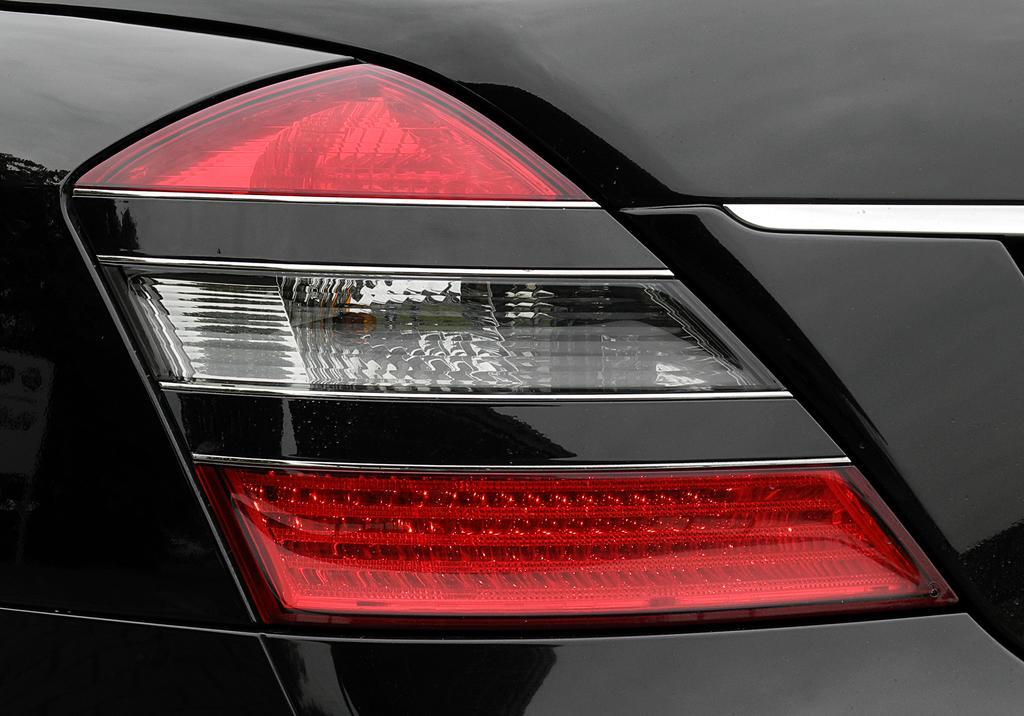Can you describe this image briefly? In this image we can see tail lamp of a car. 